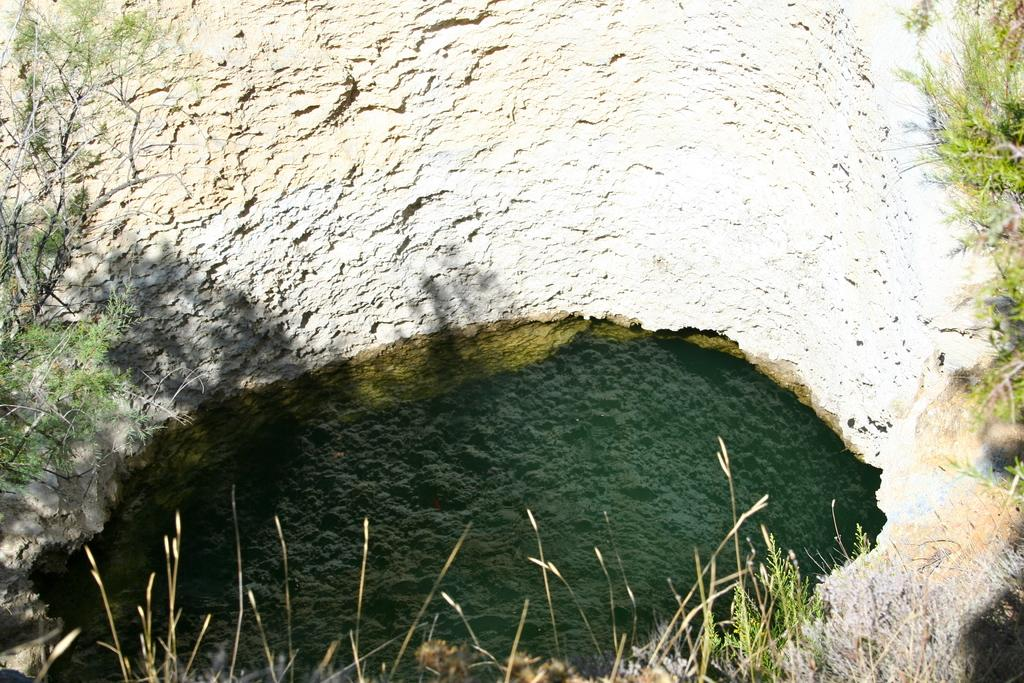What type of vegetation can be seen on both sides of the image? There are trees towards the left and right in the image. What is the ground made of at the bottom of the image? There is dried grass at the bottom of the image. What other object can be seen at the bottom of the image? There is a big stone at the bottom of the image. Can you tell me how many friends are visible in the image? There are no friends present in the image; it features trees, dried grass, and a big stone. Is there a door visible in the image? There is no door present in the image. 